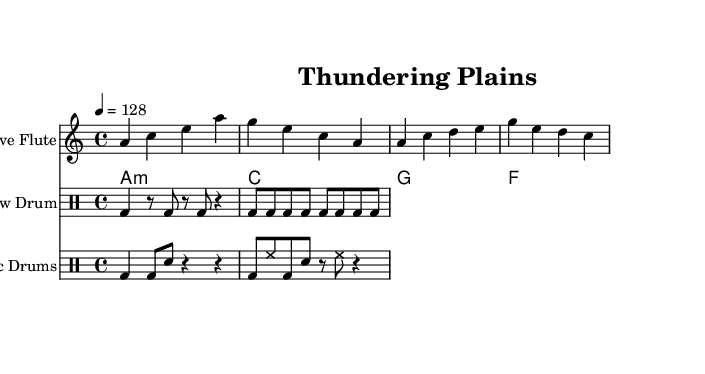What is the key signature of this music? The key signature is A minor, which is indicated by having no sharps or flats. This can be observed in the key signature symbol at the beginning of the staff.
Answer: A minor What is the time signature of the piece? The time signature is 4/4, as shown on the left side of the top staff. It means there are four beats in each measure, and each quarter note gets one beat.
Answer: 4/4 What is the tempo marking for this score? The tempo marking is 128 beats per minute, indicated by the tempo mark at the beginning of the score. It specifies the speed of the piece.
Answer: 128 How many measures does the Native Flute part have? The Native Flute part consists of four measures, which can be counted by looking at the bars in the flute staff. Each group of notes separated by vertical lines represents one measure.
Answer: 4 Which percussion instrument is specifically labeled "Pow-wow Drum"? The "Pow-wow Drum" is specifically labeled in the drum section, indicated by the title above that part of the staff. This label identifies the type of rhythm being played by that set of drums.
Answer: Pow-wow Drum Which musical section corresponds with the electronic drums? The section with "Electronic Drums" is labeled above the corresponding staff, identified by the unique set of rhythms written for that percussion type, distinct from other drum parts.
Answer: Electronic Drums What type of chords are played in the synth chords part? The chords in the synth chords part are minor and major chords, specifically indicated as "a1:m," "c," "g," and "f" in the chord mode section. This provides a harmonic foundation to the piece.
Answer: A minor, C major, G major, F major 